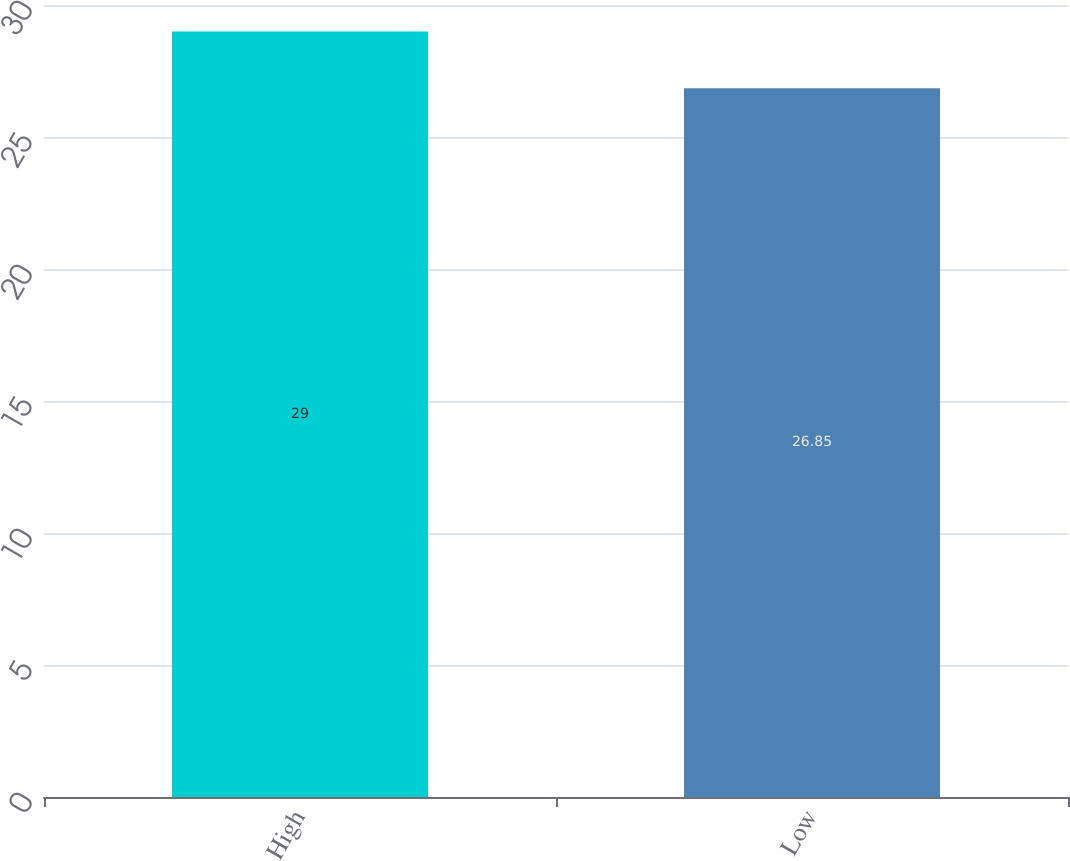Convert chart to OTSL. <chart><loc_0><loc_0><loc_500><loc_500><bar_chart><fcel>High<fcel>Low<nl><fcel>29<fcel>26.85<nl></chart> 